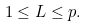Convert formula to latex. <formula><loc_0><loc_0><loc_500><loc_500>1 \leq L \leq p .</formula> 